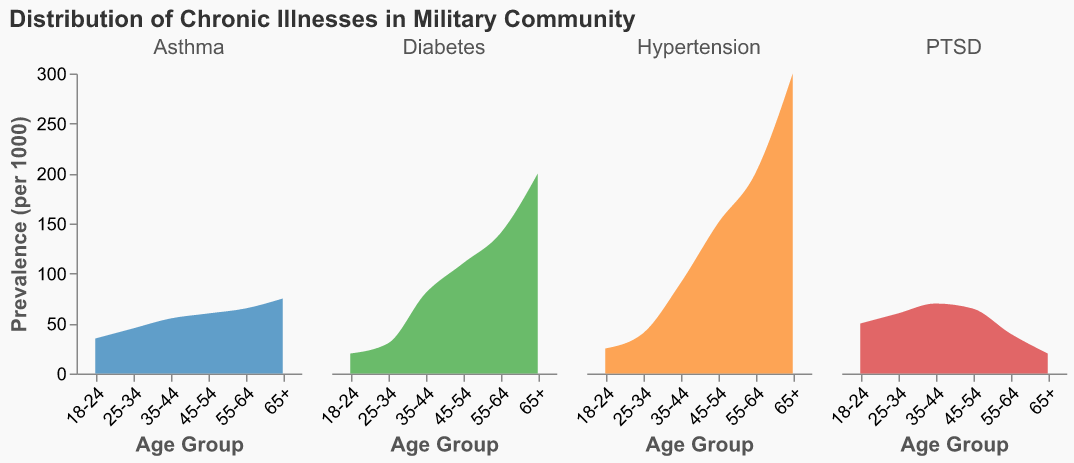What is the title of the figure? The title is prominent and located at the top of the figure. It reads "Distribution of Chronic Illnesses in Military Community."
Answer: Distribution of Chronic Illnesses in Military Community Which age group has the highest prevalence of Hypertension? Look for Hypertension across all age groups and identify the group with the highest value. The "65+" age group has the highest prevalence, with a value of 300 per 1000 people.
Answer: 65+ What is the prevalence of Asthma in the 18-24 age group? Find the "Asthma" plot and check the prevalence level on the Y-axis for the "18-24" age group. It’s recorded at 35 per 1000 people.
Answer: 35 per 1000 people What trend do you observe in the prevalence of Diabetes across age groups? Identify the Diabetes plots for each age group and observe how the values change. The trend shows an increase in prevalence with age, peaking at 200 per 1000 people in the 65+ age group.
Answer: Increasing trend Compare the prevalence of PTSD in the 18-24 and 55-64 age groups. Which group has a higher prevalence, and by how much? Locate the PTSD values for each age group. The 18-24 age group has a prevalence of 50 per 1000 people, and the 55-64 age group has 40 per 1000 people. The difference is 50 - 40 = 10.
Answer: 18-24 by 10 per 1000 people Which chronic illness shows a decreasing trend in prevalence as age increases? Examine plots for each chronic illness, noting trends. PTSD exhibits a decreasing prevalence trend as age increases.
Answer: PTSD What is the difference in the prevalence of Hypertension between the 35-44 and 45-54 age groups? Locate the Hypertension values for both groups. For 35-44, it’s 90 per 1000 people, and for 45-54, it’s 150 per 1000 people. The difference is 150 - 90 = 60 per 1000 people.
Answer: 60 per 1000 people Does any chronic illness show its highest prevalence in the 55-64 age group? Review all illnesses for their prevalence in the 55-64 age group. Hypertension (200 per 1000 people) and Diabetes (140 per 1000 people) are at their highest in this group, but these values are less than their peaks in the 65+ group. Only Asthma has its maximum value (65) here.
Answer: No How does the prevalence of Asthma in the 45-54 age group compare to the 65+ age group? Check the Asthma values for the specified age groups. For 45-54, it’s 60 per 1000 people, and for 65+, it’s 75 per 1000 people. 65+ has a higher prevalence.
Answer: 65+ is higher What is the total prevalence of Hypertension and Diabetes in the 25-34 age group? Sum the given values for Hypertension and Diabetes in the 25-34 age group. Hypertension is 40, and Diabetes is 30, making the total 40 + 30 = 70 per 1000 people.
Answer: 70 per 1000 people 